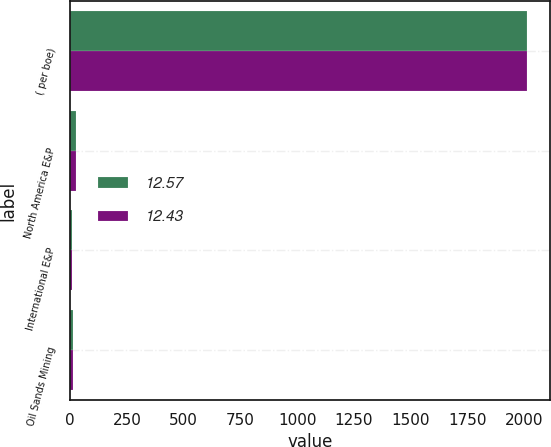<chart> <loc_0><loc_0><loc_500><loc_500><stacked_bar_chart><ecel><fcel>( per boe)<fcel>North America E&P<fcel>International E&P<fcel>Oil Sands Mining<nl><fcel>12.57<fcel>2012<fcel>23.45<fcel>8.08<fcel>12.57<nl><fcel>12.43<fcel>2011<fcel>25.15<fcel>9.7<fcel>12.43<nl></chart> 